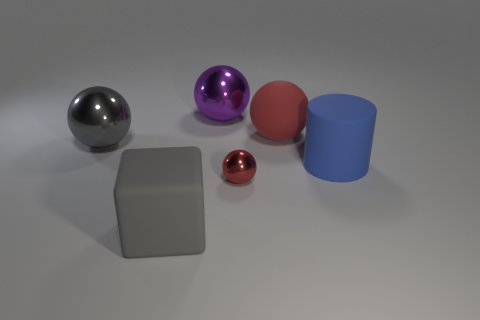Is there any other thing that has the same size as the red shiny sphere?
Ensure brevity in your answer.  No. How many rubber objects are large balls or large gray cubes?
Your answer should be compact. 2. Does the large matte object that is in front of the tiny metal thing have the same shape as the large metal object left of the big purple shiny thing?
Provide a short and direct response. No. What color is the thing that is on the left side of the red metallic thing and in front of the big rubber cylinder?
Ensure brevity in your answer.  Gray. There is a metallic ball to the left of the gray matte thing; is its size the same as the red object behind the gray metallic thing?
Offer a very short reply. Yes. What number of matte spheres are the same color as the small thing?
Offer a very short reply. 1. What number of big objects are either matte blocks or blue rubber things?
Your answer should be very brief. 2. Does the gray object that is to the left of the large rubber cube have the same material as the big purple object?
Give a very brief answer. Yes. There is a big rubber object that is on the left side of the small red metal ball; what color is it?
Make the answer very short. Gray. Are there any gray metallic objects that have the same size as the gray rubber block?
Ensure brevity in your answer.  Yes. 